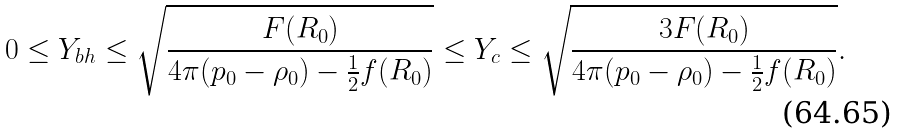<formula> <loc_0><loc_0><loc_500><loc_500>0 \leq Y _ { b h } \leq \sqrt { \frac { F ( R _ { 0 } ) } { 4 \pi ( p _ { 0 } - \rho _ { 0 } ) - \frac { 1 } { 2 } f ( R _ { 0 } ) } } \leq Y _ { c } \leq \sqrt { \frac { 3 F ( R _ { 0 } ) } { 4 \pi ( p _ { 0 } - \rho _ { 0 } ) - \frac { 1 } { 2 } f ( R _ { 0 } ) } } .</formula> 